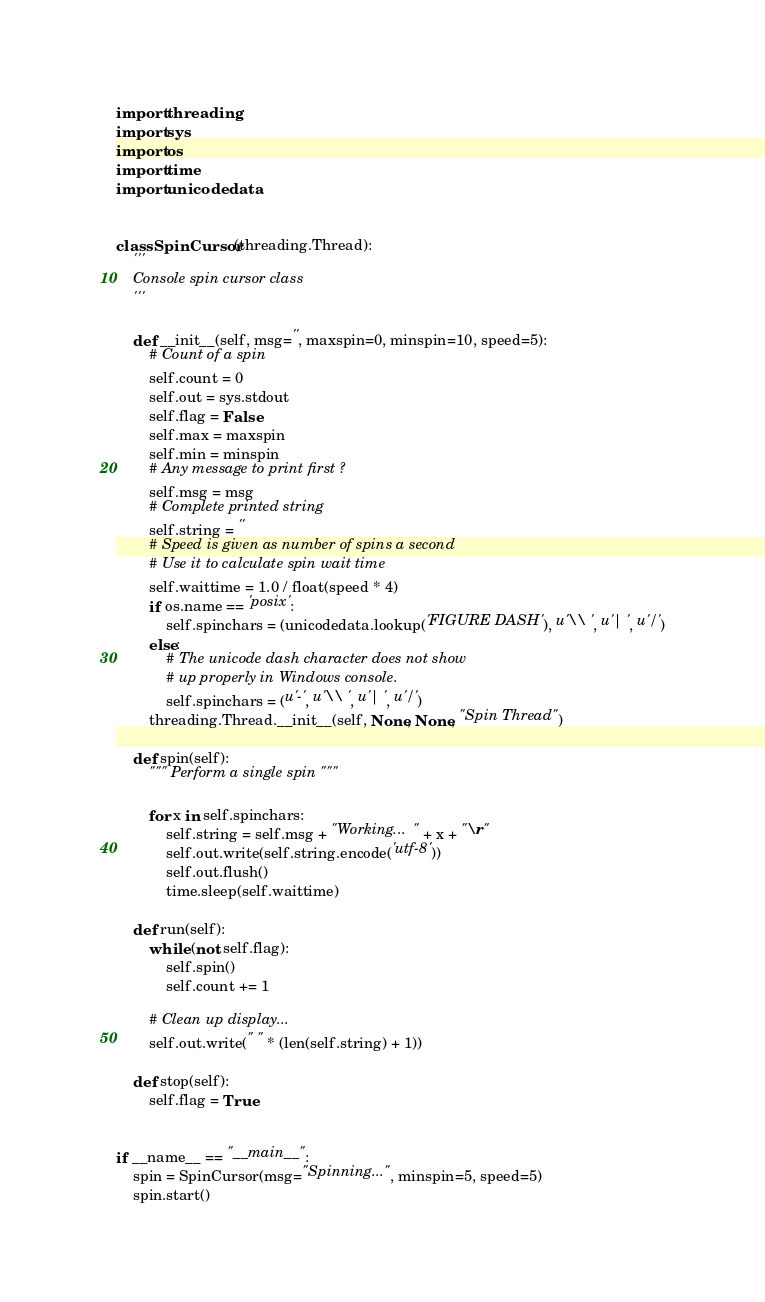<code> <loc_0><loc_0><loc_500><loc_500><_Python_>import threading
import sys
import os
import time
import unicodedata


class SpinCursor(threading.Thread):
    '''
    Console spin cursor class
    '''

    def __init__(self, msg='', maxspin=0, minspin=10, speed=5):
        # Count of a spin
        self.count = 0
        self.out = sys.stdout
        self.flag = False
        self.max = maxspin
        self.min = minspin
        # Any message to print first ?
        self.msg = msg
        # Complete printed string
        self.string = ''
        # Speed is given as number of spins a second
        # Use it to calculate spin wait time
        self.waittime = 1.0 / float(speed * 4)
        if os.name == 'posix':
            self.spinchars = (unicodedata.lookup('FIGURE DASH'), u'\\ ', u'| ', u'/ ')
        else:
            # The unicode dash character does not show
            # up properly in Windows console.
            self.spinchars = (u'-', u'\\ ', u'| ', u'/ ')
        threading.Thread.__init__(self, None, None, "Spin Thread")

    def spin(self):
        """ Perform a single spin """

        for x in self.spinchars:
            self.string = self.msg + "Working... " + x + "\r"
            self.out.write(self.string.encode('utf-8'))
            self.out.flush()
            time.sleep(self.waittime)

    def run(self):
        while (not self.flag):
            self.spin()
            self.count += 1

        # Clean up display...
        self.out.write(" " * (len(self.string) + 1))

    def stop(self):
        self.flag = True


if __name__ == "__main__":
    spin = SpinCursor(msg="Spinning...", minspin=5, speed=5)
    spin.start()
</code> 